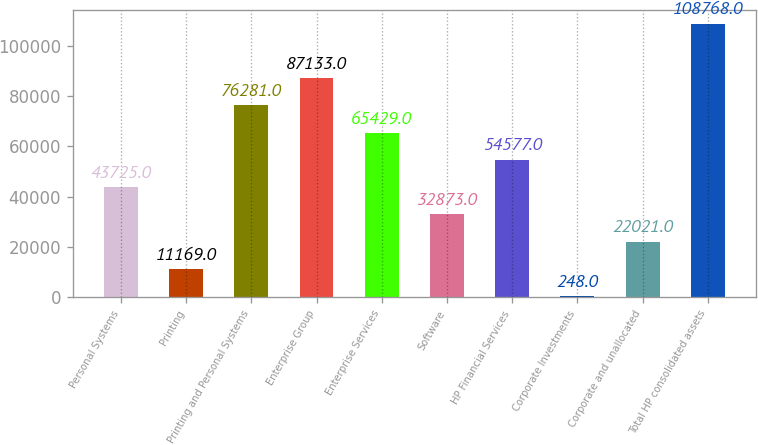<chart> <loc_0><loc_0><loc_500><loc_500><bar_chart><fcel>Personal Systems<fcel>Printing<fcel>Printing and Personal Systems<fcel>Enterprise Group<fcel>Enterprise Services<fcel>Software<fcel>HP Financial Services<fcel>Corporate Investments<fcel>Corporate and unallocated<fcel>Total HP consolidated assets<nl><fcel>43725<fcel>11169<fcel>76281<fcel>87133<fcel>65429<fcel>32873<fcel>54577<fcel>248<fcel>22021<fcel>108768<nl></chart> 